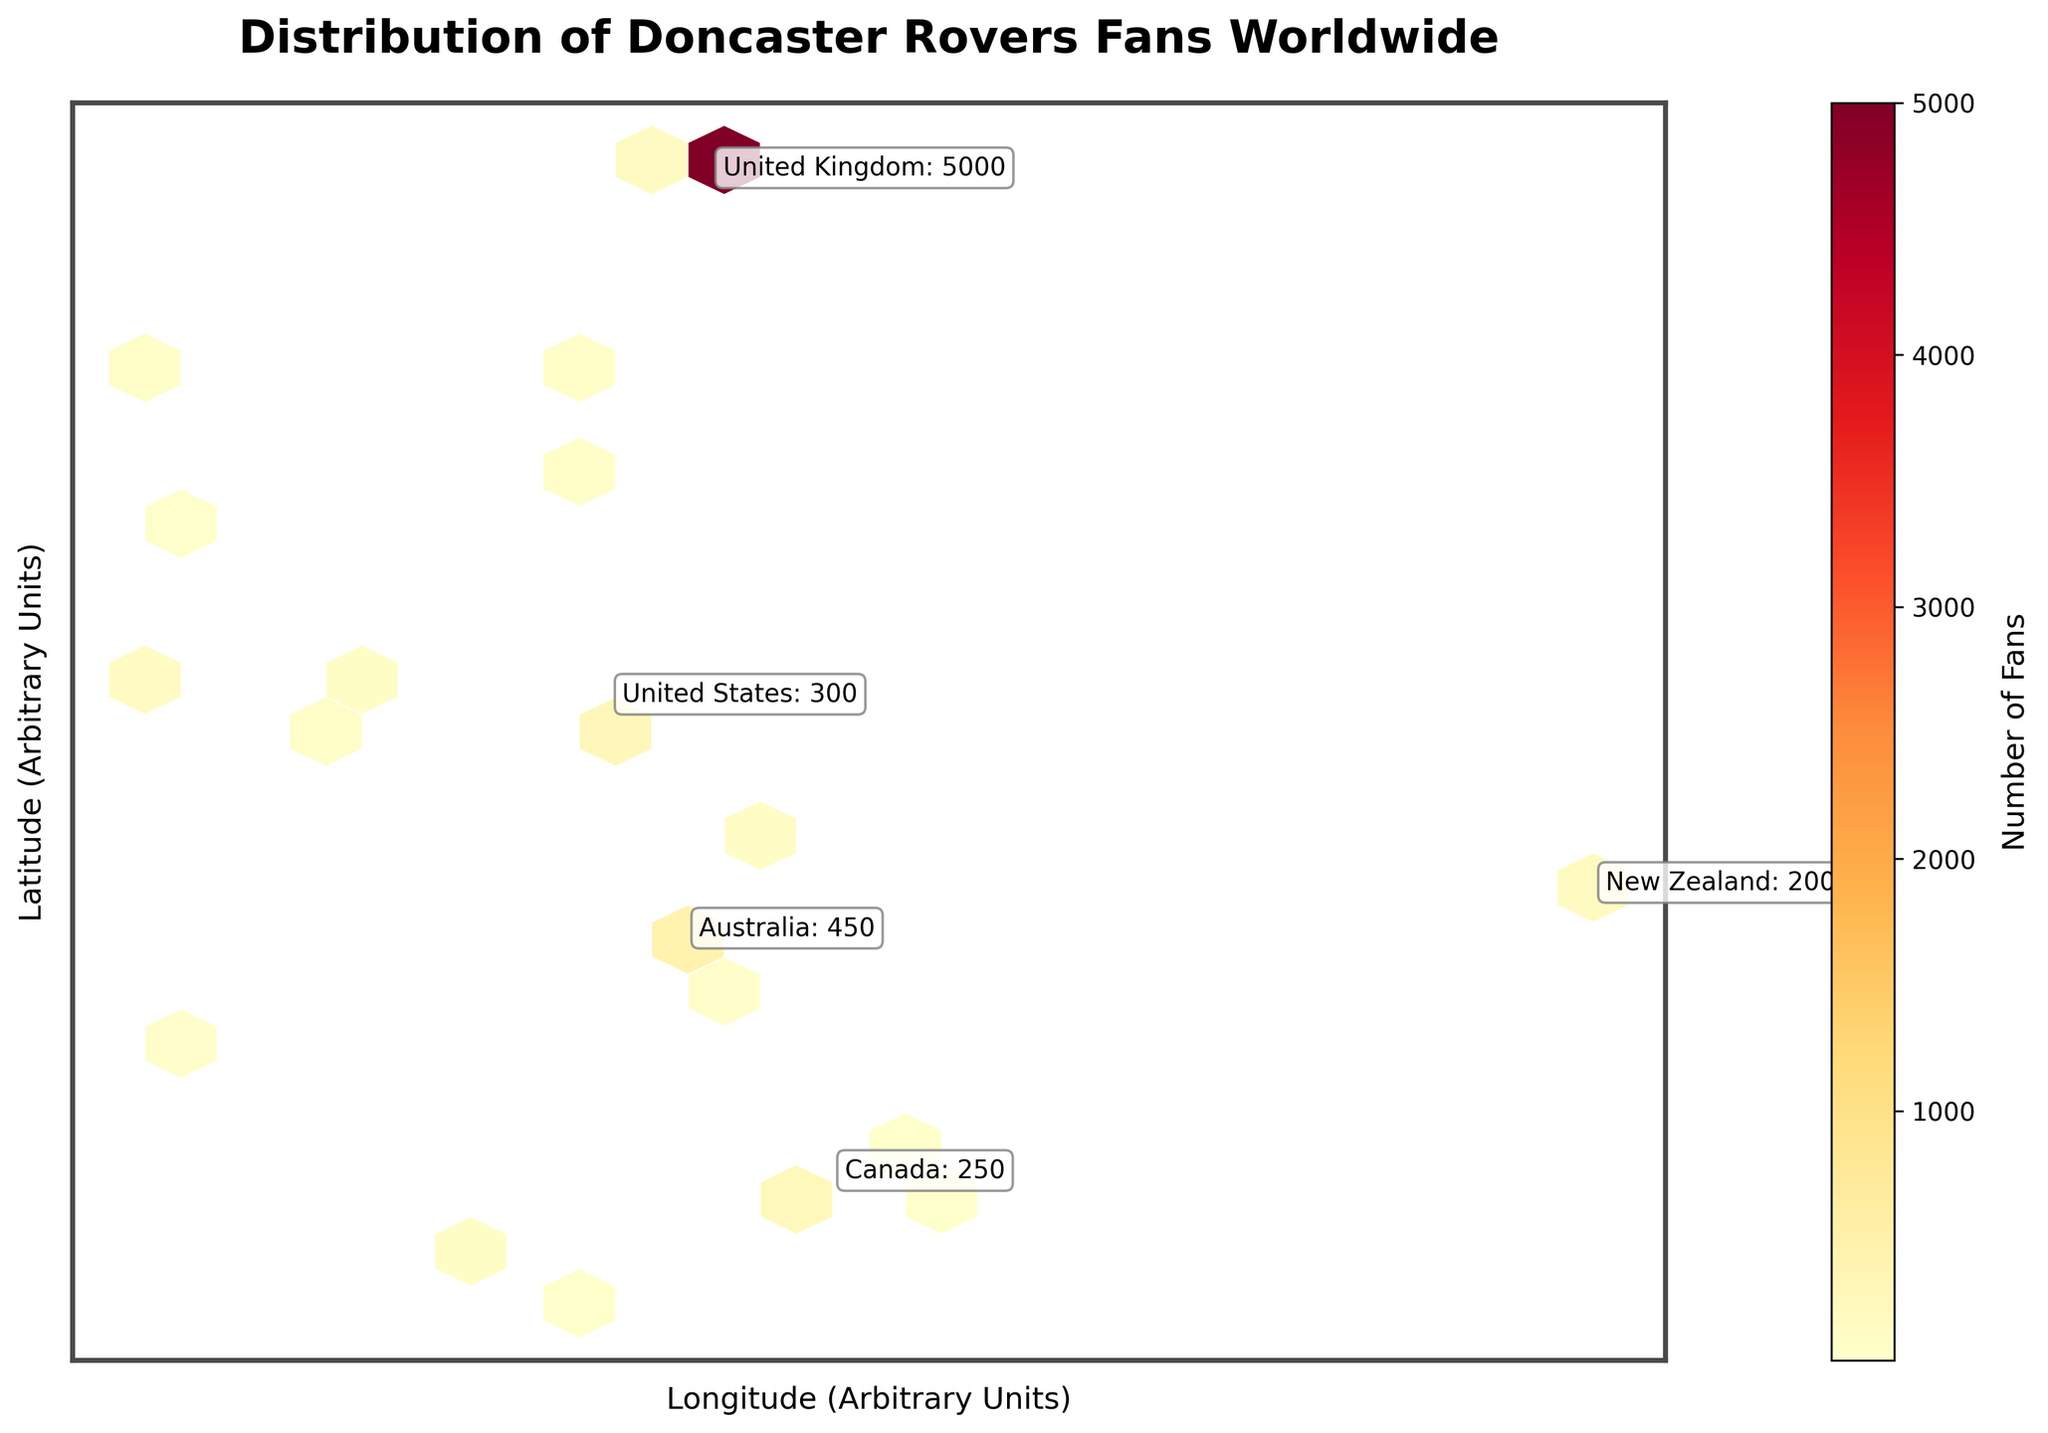what is the title of the figure? The title of the figure is displayed at the top in bold text. It reads "Distribution of Doncaster Rovers Fans Worldwide".
Answer: Distribution of Doncaster Rovers Fans Worldwide how is the concentration of fans indicated in the figure? The concentration of fans is represented by the color intensity within each hexagon on the plot. Darker hexagons indicate higher concentrations of fans.
Answer: Color intensity which country has the highest number of Doncaster Rovers fans based on the plot annotations? The annotations for the top countries are clearly labeled. The United Kingdom has 5000 fans, which is the highest number recorded.
Answer: United Kingdom how many top countries are annotated in the figure and where are they placed? The figure annotates the top five countries by fan count. Annotations are placed near the corresponding hexagons on the plot.
Answer: Five countries how is the color gradient in the color bar used for representing data? The color bar shows a gradient from light yellow to dark red, which represents increasing numbers of fans. The label "Number of Fans" clarifies this.
Answer: Light yellow to dark red gradient what does the color bar indicate in the figure? The color bar, located to the right of the hexbin plot, indicates the number of fans. The bar's gradient illustrates the range of fan counts, from fewer fans (lighter colors) to more fans (darker colors).
Answer: Number of Fans which two regions have the closest fan counts, and what are those counts? Based on the plot annotations, Ireland (Dublin) and Germany (North Rhine-Westphalia) have very close fan counts, with 180 and 150 fans respectively.
Answer: Ireland (180) and Germany (150) between whose fan counts does Australia's (New South Wales, 450 fans) count fall, based on the annotated countries? Australia's count is more than the United States (New York, 300 fans) and less than the United Kingdom (5000 fans). It falls between these two.
Answer: United States and United Kingdom what is the purpose of removing axis ticks in the figure? Removing axis ticks helps to reduce visual clutter and makes the figure more focused on the distribution of fan concentrations rather than specific coordinates.
Answer: Reduce visual clutter 